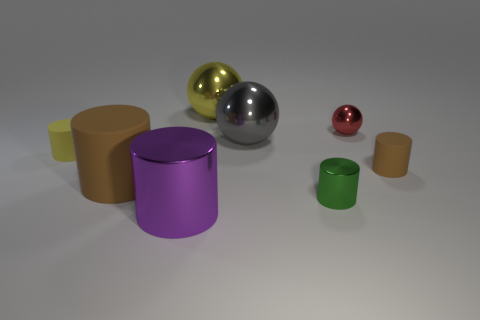What material is the small thing that is the same color as the big rubber object?
Give a very brief answer. Rubber. There is a small cylinder that is both behind the small green cylinder and to the right of the large brown matte object; what color is it?
Keep it short and to the point. Brown. Is the color of the large matte cylinder the same as the metal cylinder that is on the right side of the yellow metal ball?
Provide a succinct answer. No. What is the size of the object that is both on the right side of the gray shiny object and in front of the big brown matte object?
Provide a succinct answer. Small. What number of other things are the same color as the tiny metal sphere?
Ensure brevity in your answer.  0. How big is the rubber thing left of the large cylinder that is behind the large metal thing that is in front of the tiny yellow object?
Your response must be concise. Small. There is a tiny yellow matte thing; are there any objects on the left side of it?
Ensure brevity in your answer.  No. There is a green metallic cylinder; is it the same size as the brown thing behind the big brown rubber thing?
Offer a terse response. Yes. What number of other things are there of the same material as the yellow ball
Your response must be concise. 4. There is a metal object that is both in front of the small brown cylinder and to the right of the large purple cylinder; what shape is it?
Provide a short and direct response. Cylinder. 